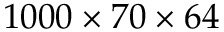Convert formula to latex. <formula><loc_0><loc_0><loc_500><loc_500>1 0 0 0 \times 7 0 \times 6 4</formula> 